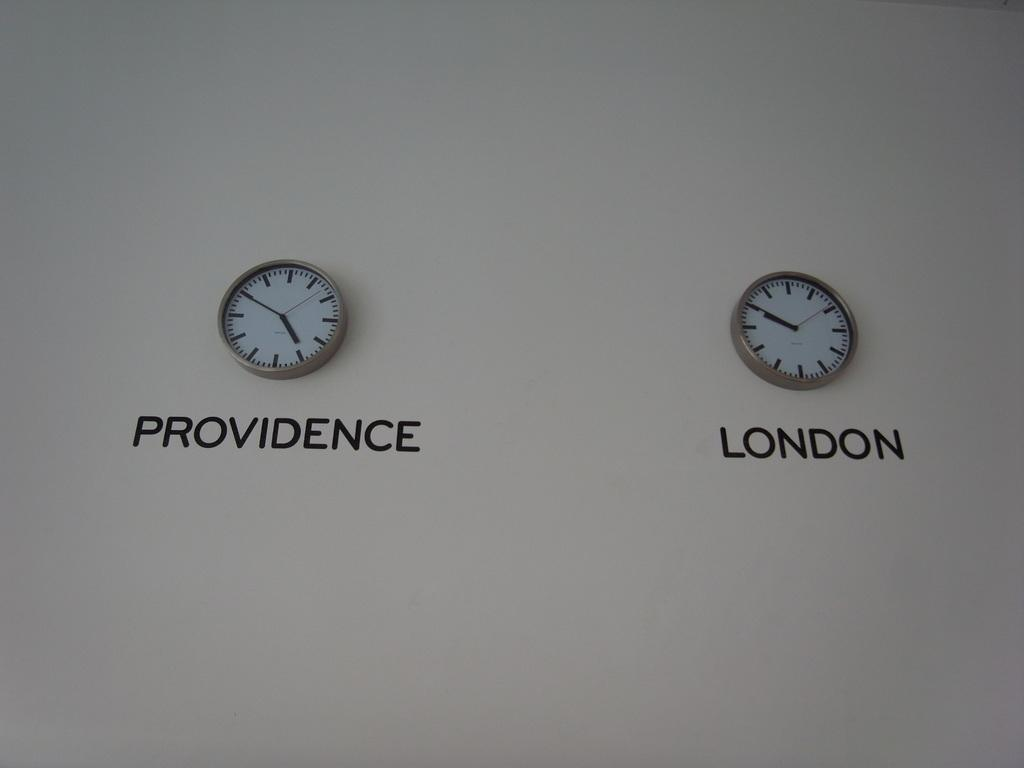<image>
Provide a brief description of the given image. Two clocks on the wall one with Providence with the time of 4:52. 